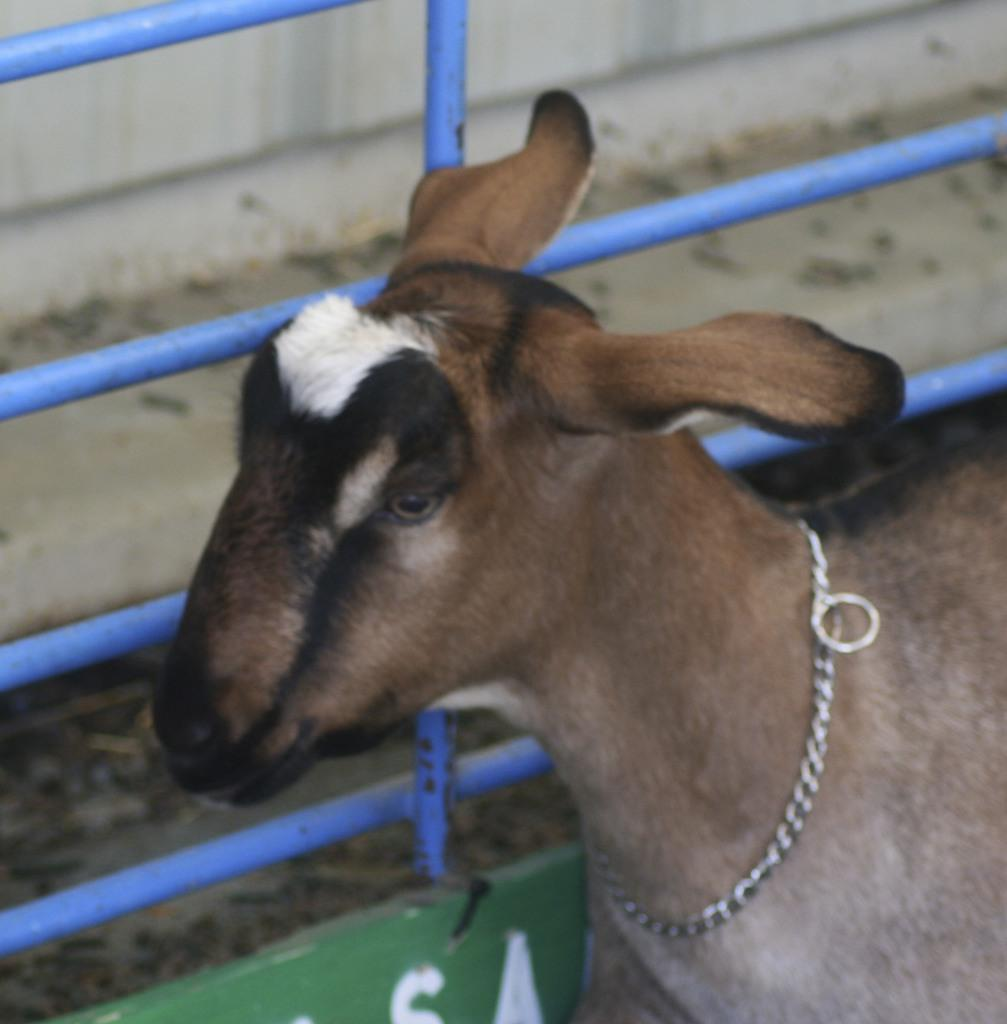What animal is present in the image? There is a goat in the image. What is unique about the goat's appearance? The goat has a belt. What color is the goat? The goat is brown in color. What type of match did the goat win in the image? There is no match or competition present in the image, so it cannot be determined if the goat won any match. 